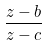<formula> <loc_0><loc_0><loc_500><loc_500>\frac { z - b } { z - c }</formula> 